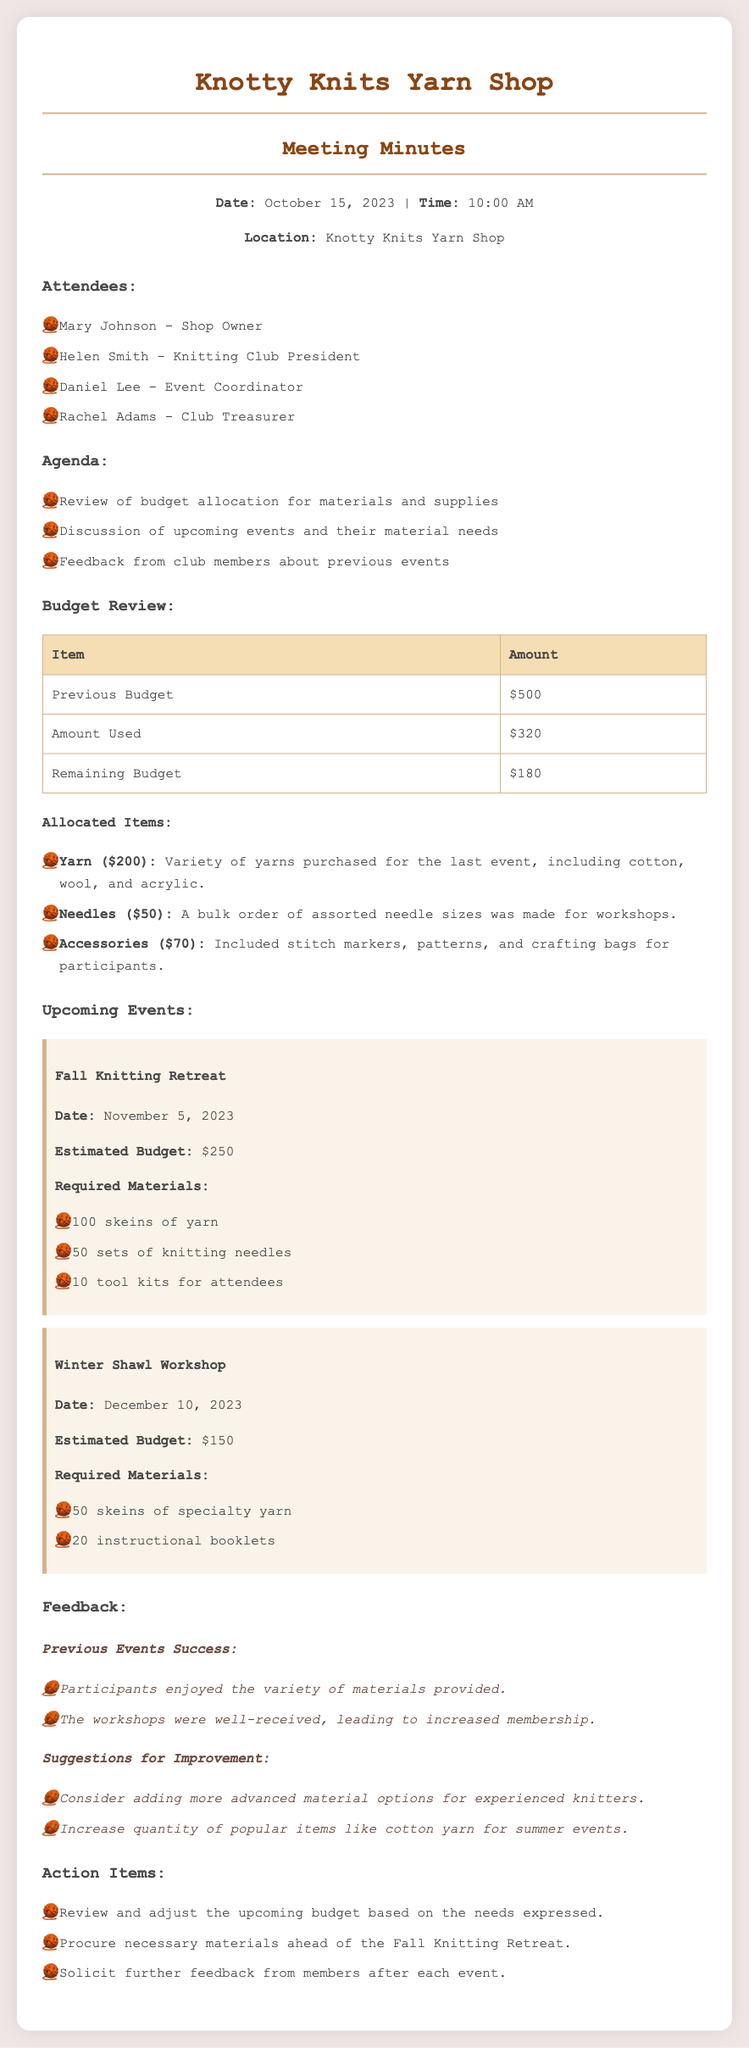What is the date of the meeting? The date of the meeting is clearly stated in the document as October 15, 2023.
Answer: October 15, 2023 Who is the shop owner? The shop owner's name is mentioned in the attendees list.
Answer: Mary Johnson What was the amount used from the budget? The amount used from the budget is provided in the budget review section of the document.
Answer: $320 How much is the estimated budget for the Fall Knitting Retreat? The estimated budget is included in the upcoming events section for the Fall Knitting Retreat.
Answer: $250 What suggestions were made for improvement? Suggestions for improvement are listed under the feedback section of the document, highlighting areas to enhance future events.
Answer: Add more advanced material options for experienced knitters What is the remaining budget after the last event? The remaining budget is calculated based on previous budget and amount used.
Answer: $180 What materials are required for the Winter Shawl Workshop? The required materials are listed in the upcoming events section for the Winter Shawl Workshop.
Answer: 50 skeins of specialty yarn, 20 instructional booklets How many attendees are suggested for the Fall event? The document does not specify a number of attendees for the Fall event, focusing instead on materials needed.
Answer: Not specified What action item involves soliciting feedback? One of the action items listed explicitly mentions soliciting feedback from members after each event.
Answer: Solicit further feedback from members after each event 